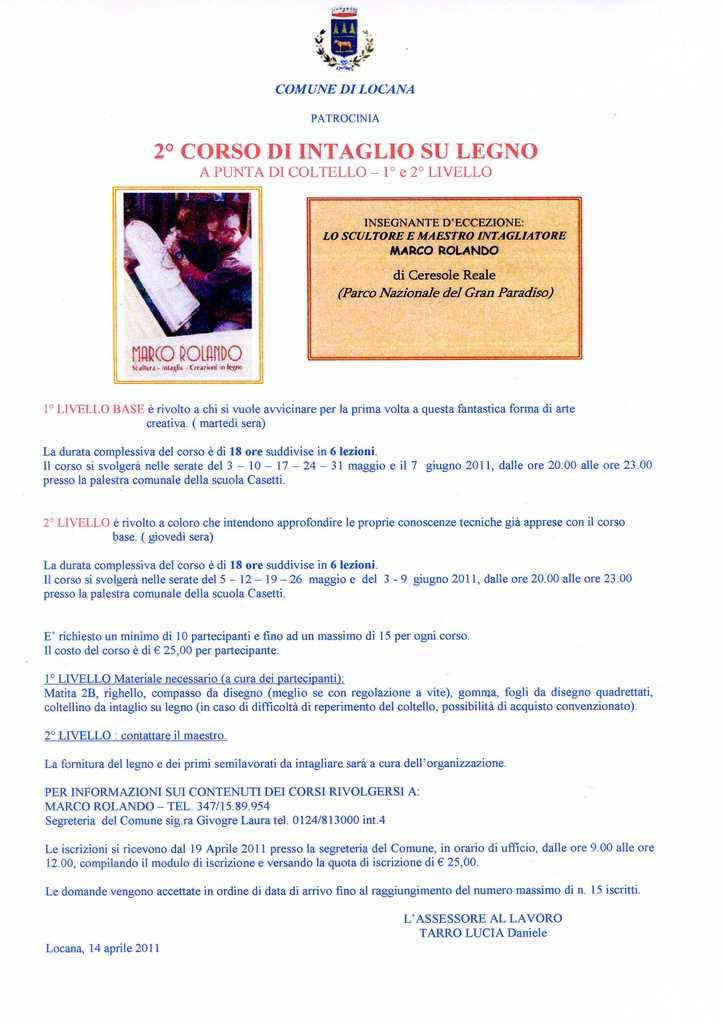What is present in the image that contains information or a message? There is a poster in the image that contains information or a message. What can be found on the poster besides the written matter? There is a person's image on the poster. Can you see any baskets or balloons in the image? No, there are no baskets or balloons present in the image. Is there a harbor visible in the image? No, there is no harbor visible in the image. 